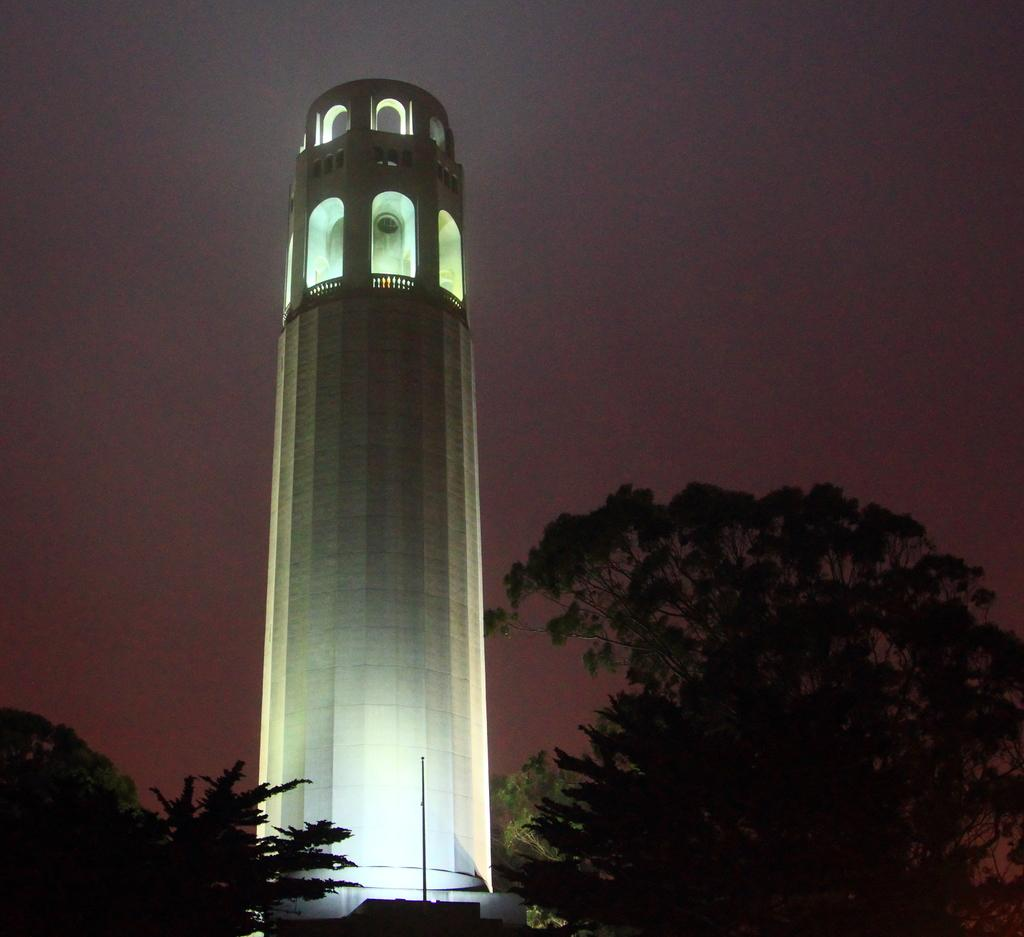What can be seen in the background of the image? The sky is visible in the background of the image. What type of natural elements are present in the image? There are trees in the image. What man-made structure is present in the image? There is a pole in the image. What is the main subject of the image? The main focus of the image is a lighthouse. How does the lighthouse fold its brush in the image? There is no brush present in the image, and lighthouses do not have the ability to fold anything. 